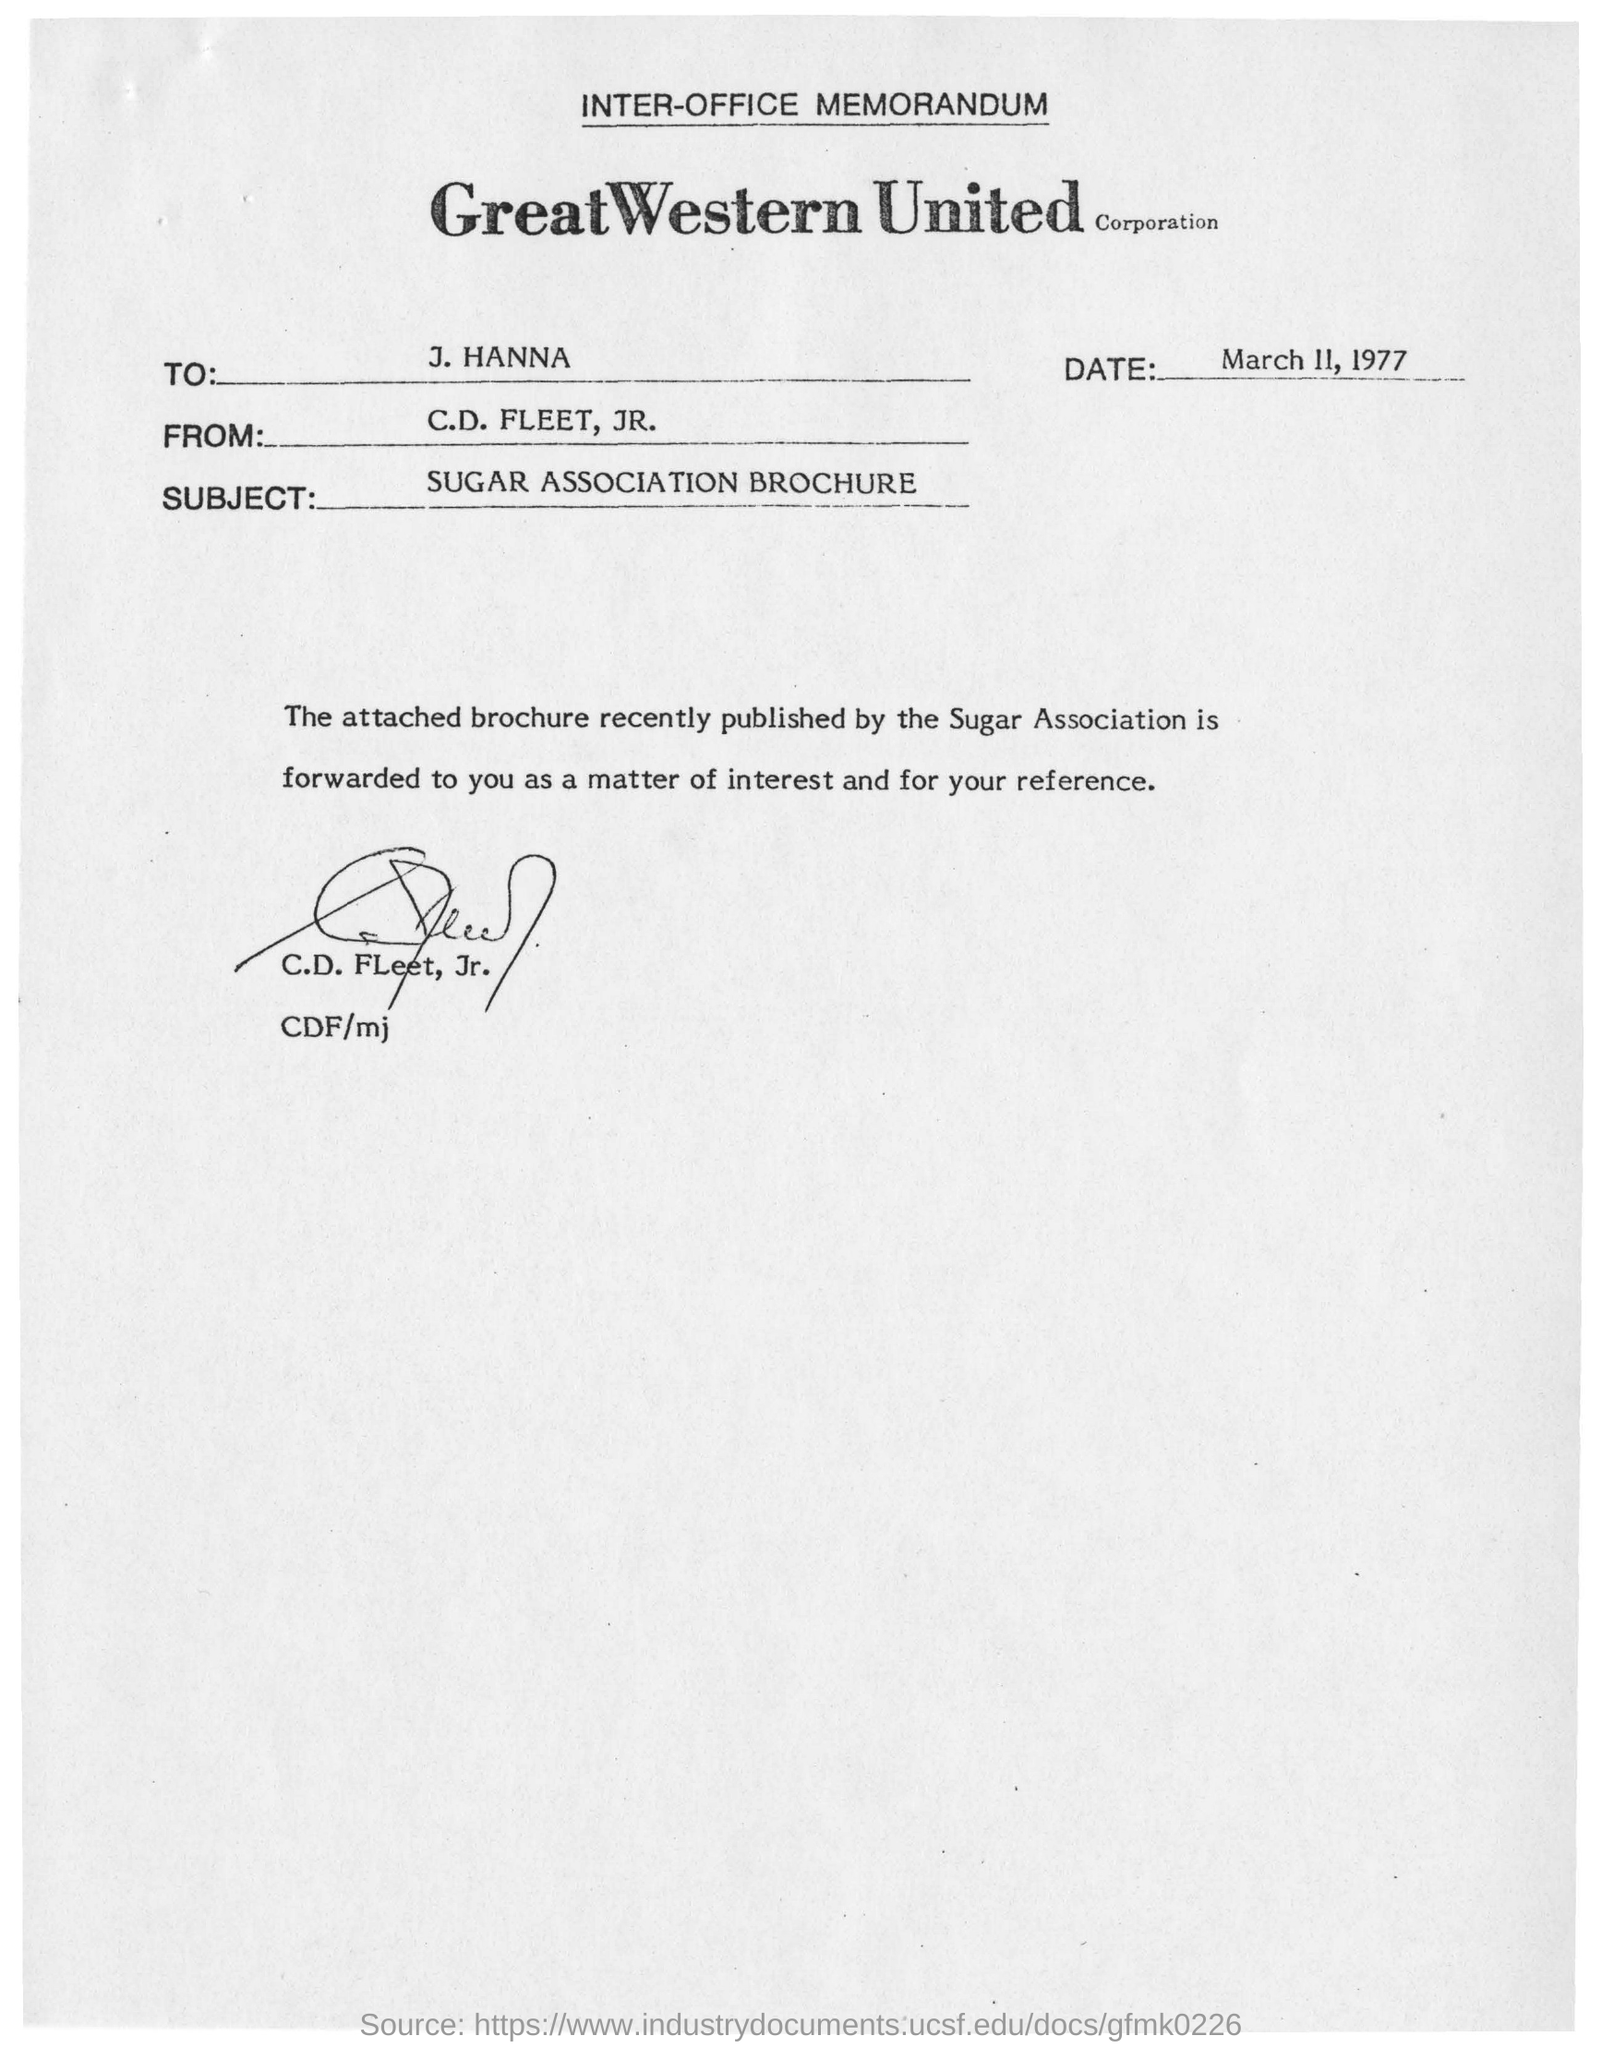To Whom is this memorandum addressed to?
Your answer should be very brief. J. Hanna. What is the date in the memorandum?
Offer a terse response. March 11, 1977. What is the subject of the memorandum?
Give a very brief answer. Sugar association brochure. 